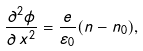<formula> <loc_0><loc_0><loc_500><loc_500>\frac { \partial ^ { 2 } \phi } { \partial \, x ^ { 2 } } = \frac { e } { \varepsilon _ { 0 } } ( n - n _ { 0 } ) ,</formula> 